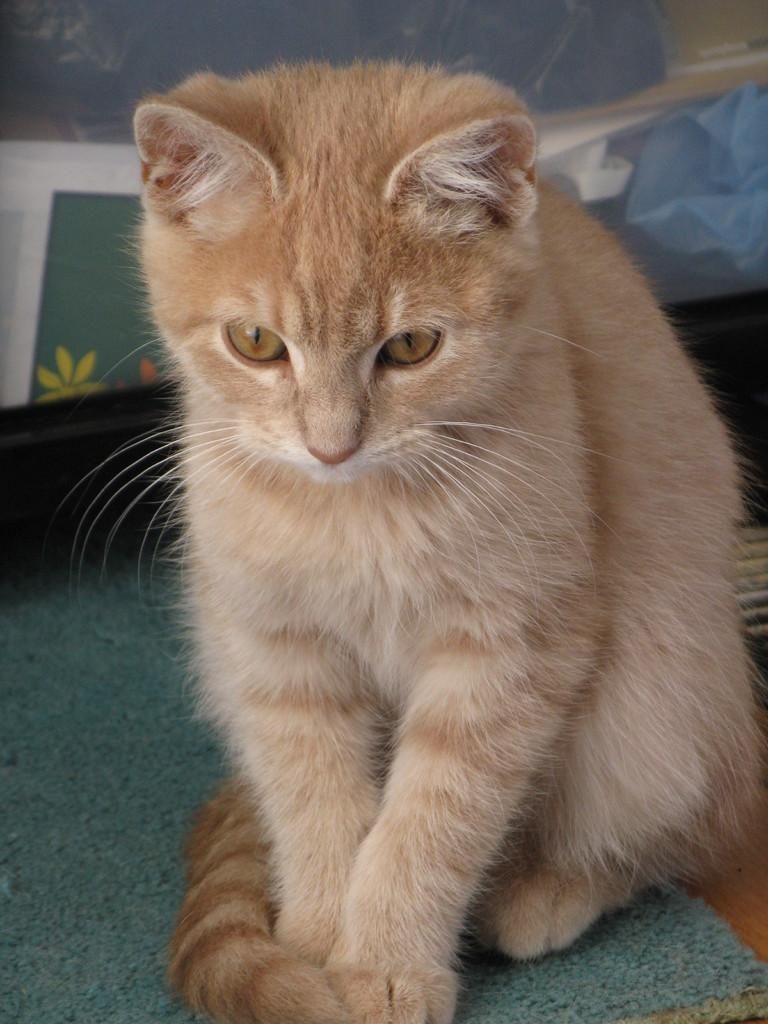What type of animal is in the image? There is a cat in the image. What is the cat sitting on? The cat is on a cloth. What else can be seen in the image besides the cat? There is a cover with a design in the image. What type of bean is visible in the image? There is no bean present in the image. What kind of haircut does the cat have in the image? The image does not show the cat's haircut, as it only shows the cat sitting on a cloth and a cover with a design. 